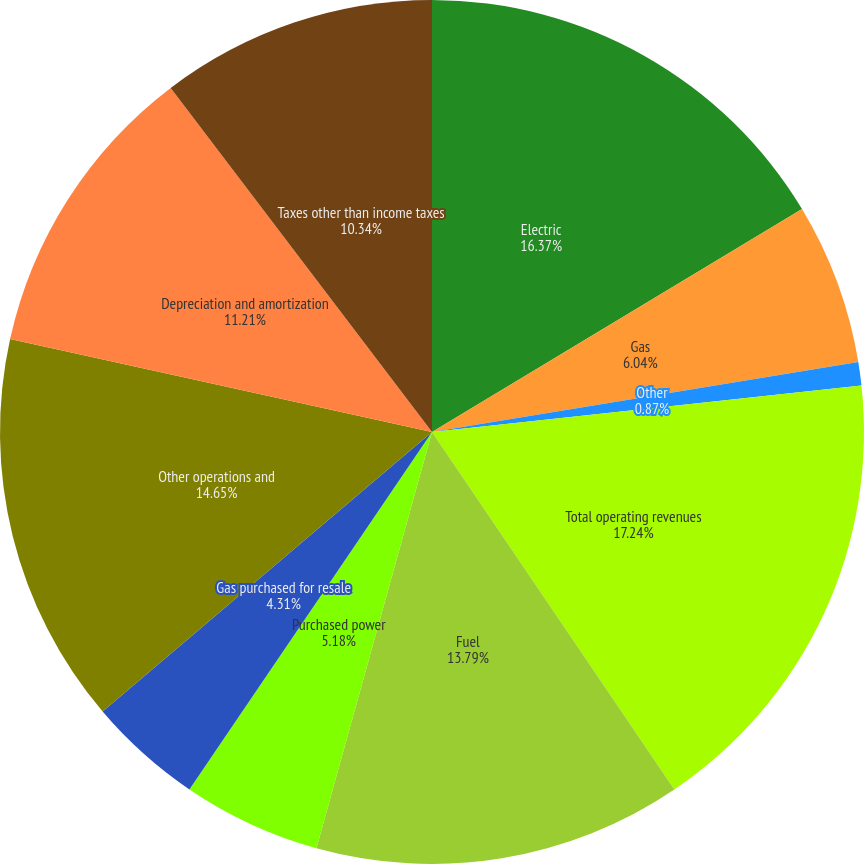Convert chart to OTSL. <chart><loc_0><loc_0><loc_500><loc_500><pie_chart><fcel>Electric<fcel>Gas<fcel>Other<fcel>Total operating revenues<fcel>Fuel<fcel>Purchased power<fcel>Gas purchased for resale<fcel>Other operations and<fcel>Depreciation and amortization<fcel>Taxes other than income taxes<nl><fcel>16.37%<fcel>6.04%<fcel>0.87%<fcel>17.24%<fcel>13.79%<fcel>5.18%<fcel>4.31%<fcel>14.65%<fcel>11.21%<fcel>10.34%<nl></chart> 